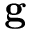<formula> <loc_0><loc_0><loc_500><loc_500>g</formula> 